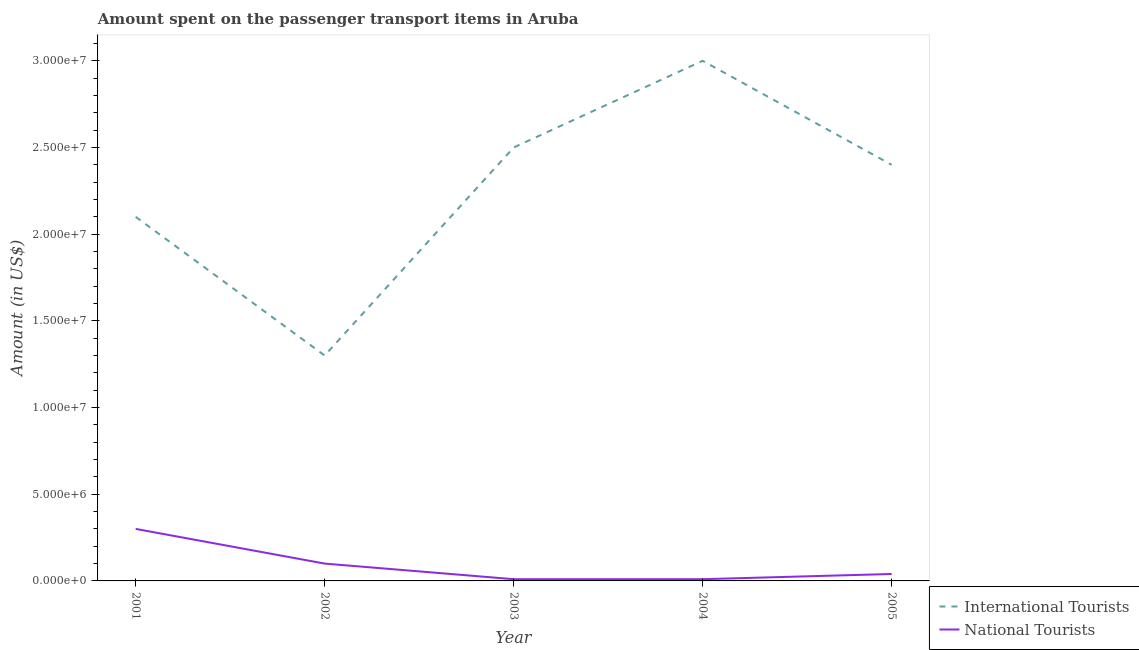What is the amount spent on transport items of national tourists in 2001?
Make the answer very short. 3.00e+06. Across all years, what is the maximum amount spent on transport items of international tourists?
Offer a very short reply. 3.00e+07. Across all years, what is the minimum amount spent on transport items of international tourists?
Give a very brief answer. 1.30e+07. In which year was the amount spent on transport items of national tourists minimum?
Offer a terse response. 2003. What is the total amount spent on transport items of international tourists in the graph?
Ensure brevity in your answer.  1.13e+08. What is the difference between the amount spent on transport items of national tourists in 2001 and that in 2003?
Offer a terse response. 2.90e+06. What is the difference between the amount spent on transport items of national tourists in 2003 and the amount spent on transport items of international tourists in 2002?
Provide a short and direct response. -1.29e+07. What is the average amount spent on transport items of international tourists per year?
Provide a short and direct response. 2.26e+07. In the year 2003, what is the difference between the amount spent on transport items of national tourists and amount spent on transport items of international tourists?
Keep it short and to the point. -2.49e+07. What is the ratio of the amount spent on transport items of international tourists in 2003 to that in 2005?
Offer a very short reply. 1.04. What is the difference between the highest and the second highest amount spent on transport items of international tourists?
Keep it short and to the point. 5.00e+06. What is the difference between the highest and the lowest amount spent on transport items of international tourists?
Offer a very short reply. 1.70e+07. In how many years, is the amount spent on transport items of international tourists greater than the average amount spent on transport items of international tourists taken over all years?
Offer a terse response. 3. Is the amount spent on transport items of national tourists strictly greater than the amount spent on transport items of international tourists over the years?
Keep it short and to the point. No. Is the amount spent on transport items of international tourists strictly less than the amount spent on transport items of national tourists over the years?
Offer a terse response. No. How many lines are there?
Your answer should be compact. 2. What is the difference between two consecutive major ticks on the Y-axis?
Keep it short and to the point. 5.00e+06. Are the values on the major ticks of Y-axis written in scientific E-notation?
Your response must be concise. Yes. Where does the legend appear in the graph?
Provide a succinct answer. Bottom right. How are the legend labels stacked?
Offer a terse response. Vertical. What is the title of the graph?
Make the answer very short. Amount spent on the passenger transport items in Aruba. What is the label or title of the X-axis?
Your response must be concise. Year. What is the Amount (in US$) of International Tourists in 2001?
Make the answer very short. 2.10e+07. What is the Amount (in US$) in National Tourists in 2001?
Give a very brief answer. 3.00e+06. What is the Amount (in US$) in International Tourists in 2002?
Keep it short and to the point. 1.30e+07. What is the Amount (in US$) in International Tourists in 2003?
Offer a very short reply. 2.50e+07. What is the Amount (in US$) in International Tourists in 2004?
Keep it short and to the point. 3.00e+07. What is the Amount (in US$) in National Tourists in 2004?
Your answer should be compact. 1.00e+05. What is the Amount (in US$) in International Tourists in 2005?
Provide a succinct answer. 2.40e+07. Across all years, what is the maximum Amount (in US$) of International Tourists?
Provide a succinct answer. 3.00e+07. Across all years, what is the maximum Amount (in US$) in National Tourists?
Your response must be concise. 3.00e+06. Across all years, what is the minimum Amount (in US$) of International Tourists?
Make the answer very short. 1.30e+07. Across all years, what is the minimum Amount (in US$) of National Tourists?
Provide a short and direct response. 1.00e+05. What is the total Amount (in US$) of International Tourists in the graph?
Make the answer very short. 1.13e+08. What is the total Amount (in US$) of National Tourists in the graph?
Your response must be concise. 4.60e+06. What is the difference between the Amount (in US$) in International Tourists in 2001 and that in 2002?
Your answer should be very brief. 8.00e+06. What is the difference between the Amount (in US$) in National Tourists in 2001 and that in 2003?
Provide a short and direct response. 2.90e+06. What is the difference between the Amount (in US$) in International Tourists in 2001 and that in 2004?
Ensure brevity in your answer.  -9.00e+06. What is the difference between the Amount (in US$) of National Tourists in 2001 and that in 2004?
Your answer should be compact. 2.90e+06. What is the difference between the Amount (in US$) in National Tourists in 2001 and that in 2005?
Ensure brevity in your answer.  2.60e+06. What is the difference between the Amount (in US$) of International Tourists in 2002 and that in 2003?
Ensure brevity in your answer.  -1.20e+07. What is the difference between the Amount (in US$) in International Tourists in 2002 and that in 2004?
Ensure brevity in your answer.  -1.70e+07. What is the difference between the Amount (in US$) in International Tourists in 2002 and that in 2005?
Offer a very short reply. -1.10e+07. What is the difference between the Amount (in US$) of National Tourists in 2002 and that in 2005?
Provide a succinct answer. 6.00e+05. What is the difference between the Amount (in US$) of International Tourists in 2003 and that in 2004?
Provide a short and direct response. -5.00e+06. What is the difference between the Amount (in US$) of International Tourists in 2001 and the Amount (in US$) of National Tourists in 2002?
Provide a short and direct response. 2.00e+07. What is the difference between the Amount (in US$) of International Tourists in 2001 and the Amount (in US$) of National Tourists in 2003?
Ensure brevity in your answer.  2.09e+07. What is the difference between the Amount (in US$) in International Tourists in 2001 and the Amount (in US$) in National Tourists in 2004?
Offer a very short reply. 2.09e+07. What is the difference between the Amount (in US$) in International Tourists in 2001 and the Amount (in US$) in National Tourists in 2005?
Provide a succinct answer. 2.06e+07. What is the difference between the Amount (in US$) of International Tourists in 2002 and the Amount (in US$) of National Tourists in 2003?
Provide a succinct answer. 1.29e+07. What is the difference between the Amount (in US$) of International Tourists in 2002 and the Amount (in US$) of National Tourists in 2004?
Your response must be concise. 1.29e+07. What is the difference between the Amount (in US$) in International Tourists in 2002 and the Amount (in US$) in National Tourists in 2005?
Provide a succinct answer. 1.26e+07. What is the difference between the Amount (in US$) of International Tourists in 2003 and the Amount (in US$) of National Tourists in 2004?
Keep it short and to the point. 2.49e+07. What is the difference between the Amount (in US$) in International Tourists in 2003 and the Amount (in US$) in National Tourists in 2005?
Ensure brevity in your answer.  2.46e+07. What is the difference between the Amount (in US$) of International Tourists in 2004 and the Amount (in US$) of National Tourists in 2005?
Make the answer very short. 2.96e+07. What is the average Amount (in US$) in International Tourists per year?
Keep it short and to the point. 2.26e+07. What is the average Amount (in US$) in National Tourists per year?
Keep it short and to the point. 9.20e+05. In the year 2001, what is the difference between the Amount (in US$) of International Tourists and Amount (in US$) of National Tourists?
Make the answer very short. 1.80e+07. In the year 2003, what is the difference between the Amount (in US$) of International Tourists and Amount (in US$) of National Tourists?
Make the answer very short. 2.49e+07. In the year 2004, what is the difference between the Amount (in US$) of International Tourists and Amount (in US$) of National Tourists?
Provide a succinct answer. 2.99e+07. In the year 2005, what is the difference between the Amount (in US$) of International Tourists and Amount (in US$) of National Tourists?
Give a very brief answer. 2.36e+07. What is the ratio of the Amount (in US$) in International Tourists in 2001 to that in 2002?
Your answer should be compact. 1.62. What is the ratio of the Amount (in US$) in International Tourists in 2001 to that in 2003?
Make the answer very short. 0.84. What is the ratio of the Amount (in US$) of National Tourists in 2001 to that in 2004?
Provide a short and direct response. 30. What is the ratio of the Amount (in US$) of National Tourists in 2001 to that in 2005?
Provide a succinct answer. 7.5. What is the ratio of the Amount (in US$) in International Tourists in 2002 to that in 2003?
Provide a succinct answer. 0.52. What is the ratio of the Amount (in US$) of National Tourists in 2002 to that in 2003?
Ensure brevity in your answer.  10. What is the ratio of the Amount (in US$) of International Tourists in 2002 to that in 2004?
Provide a succinct answer. 0.43. What is the ratio of the Amount (in US$) of National Tourists in 2002 to that in 2004?
Provide a succinct answer. 10. What is the ratio of the Amount (in US$) of International Tourists in 2002 to that in 2005?
Offer a very short reply. 0.54. What is the ratio of the Amount (in US$) of National Tourists in 2002 to that in 2005?
Provide a succinct answer. 2.5. What is the ratio of the Amount (in US$) of International Tourists in 2003 to that in 2004?
Offer a very short reply. 0.83. What is the ratio of the Amount (in US$) in International Tourists in 2003 to that in 2005?
Offer a very short reply. 1.04. What is the ratio of the Amount (in US$) in International Tourists in 2004 to that in 2005?
Offer a very short reply. 1.25. What is the difference between the highest and the lowest Amount (in US$) in International Tourists?
Your answer should be very brief. 1.70e+07. What is the difference between the highest and the lowest Amount (in US$) in National Tourists?
Your response must be concise. 2.90e+06. 